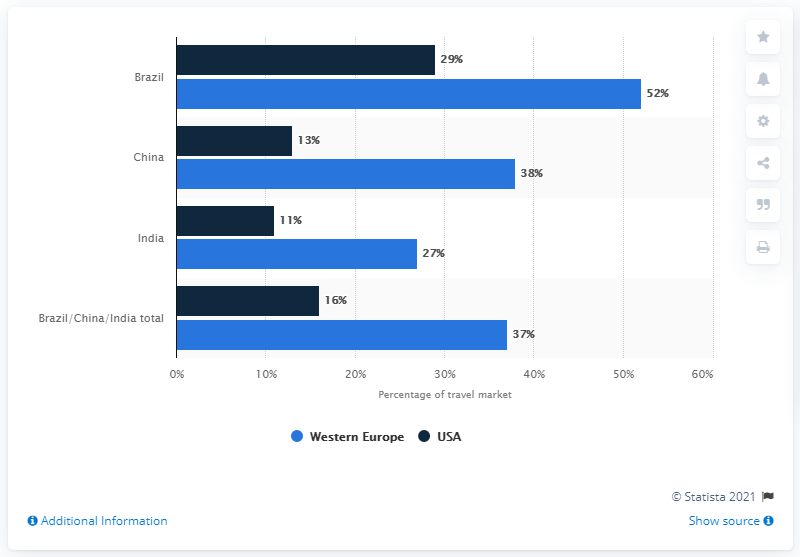Highlight a few significant elements in this photo. The difference between the shortest light blue bar and the longest dark blue bar is -2. What is the difference between the longest and the shortest dark blue bar? Thirteen. 